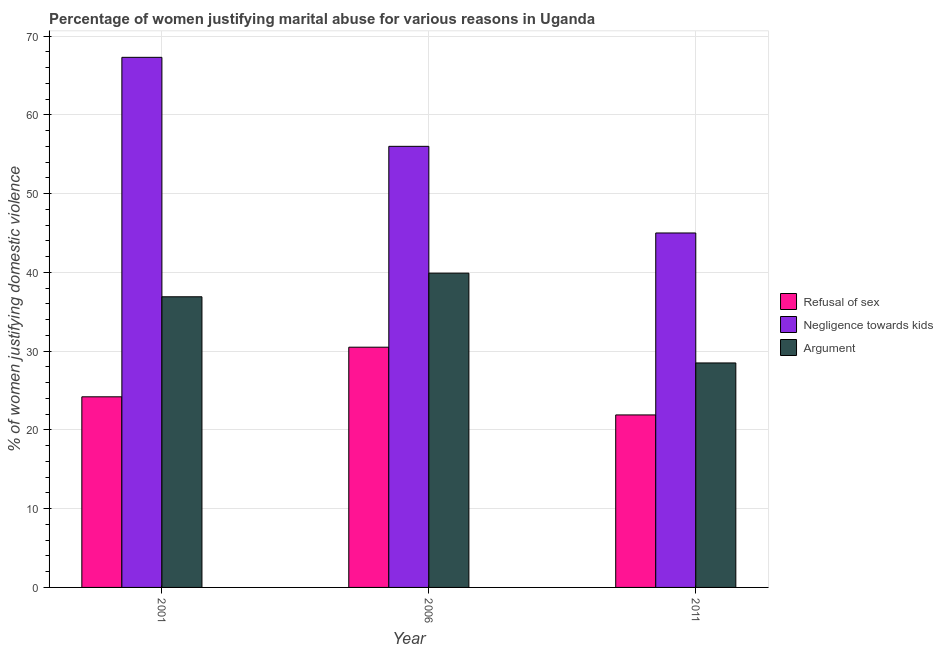How many different coloured bars are there?
Your answer should be very brief. 3. Are the number of bars per tick equal to the number of legend labels?
Ensure brevity in your answer.  Yes. How many bars are there on the 1st tick from the left?
Offer a terse response. 3. How many bars are there on the 2nd tick from the right?
Offer a very short reply. 3. In how many cases, is the number of bars for a given year not equal to the number of legend labels?
Provide a succinct answer. 0. What is the percentage of women justifying domestic violence due to refusal of sex in 2011?
Provide a succinct answer. 21.9. Across all years, what is the maximum percentage of women justifying domestic violence due to refusal of sex?
Make the answer very short. 30.5. In which year was the percentage of women justifying domestic violence due to arguments minimum?
Your answer should be very brief. 2011. What is the total percentage of women justifying domestic violence due to refusal of sex in the graph?
Offer a terse response. 76.6. What is the difference between the percentage of women justifying domestic violence due to refusal of sex in 2001 and that in 2006?
Ensure brevity in your answer.  -6.3. What is the difference between the percentage of women justifying domestic violence due to refusal of sex in 2006 and the percentage of women justifying domestic violence due to arguments in 2001?
Your answer should be very brief. 6.3. What is the average percentage of women justifying domestic violence due to negligence towards kids per year?
Give a very brief answer. 56.1. In how many years, is the percentage of women justifying domestic violence due to refusal of sex greater than 8 %?
Offer a very short reply. 3. What is the ratio of the percentage of women justifying domestic violence due to negligence towards kids in 2006 to that in 2011?
Give a very brief answer. 1.24. Is the difference between the percentage of women justifying domestic violence due to arguments in 2001 and 2006 greater than the difference between the percentage of women justifying domestic violence due to negligence towards kids in 2001 and 2006?
Give a very brief answer. No. What is the difference between the highest and the second highest percentage of women justifying domestic violence due to negligence towards kids?
Make the answer very short. 11.3. What is the difference between the highest and the lowest percentage of women justifying domestic violence due to negligence towards kids?
Your answer should be very brief. 22.3. Is the sum of the percentage of women justifying domestic violence due to refusal of sex in 2006 and 2011 greater than the maximum percentage of women justifying domestic violence due to arguments across all years?
Your response must be concise. Yes. What does the 1st bar from the left in 2011 represents?
Provide a succinct answer. Refusal of sex. What does the 1st bar from the right in 2011 represents?
Provide a succinct answer. Argument. Is it the case that in every year, the sum of the percentage of women justifying domestic violence due to refusal of sex and percentage of women justifying domestic violence due to negligence towards kids is greater than the percentage of women justifying domestic violence due to arguments?
Make the answer very short. Yes. Are all the bars in the graph horizontal?
Give a very brief answer. No. How many years are there in the graph?
Make the answer very short. 3. Are the values on the major ticks of Y-axis written in scientific E-notation?
Provide a short and direct response. No. Does the graph contain any zero values?
Your answer should be compact. No. Does the graph contain grids?
Give a very brief answer. Yes. Where does the legend appear in the graph?
Provide a succinct answer. Center right. How are the legend labels stacked?
Ensure brevity in your answer.  Vertical. What is the title of the graph?
Keep it short and to the point. Percentage of women justifying marital abuse for various reasons in Uganda. Does "Self-employed" appear as one of the legend labels in the graph?
Provide a succinct answer. No. What is the label or title of the Y-axis?
Make the answer very short. % of women justifying domestic violence. What is the % of women justifying domestic violence in Refusal of sex in 2001?
Ensure brevity in your answer.  24.2. What is the % of women justifying domestic violence of Negligence towards kids in 2001?
Your response must be concise. 67.3. What is the % of women justifying domestic violence of Argument in 2001?
Your response must be concise. 36.9. What is the % of women justifying domestic violence in Refusal of sex in 2006?
Your answer should be compact. 30.5. What is the % of women justifying domestic violence in Argument in 2006?
Make the answer very short. 39.9. What is the % of women justifying domestic violence of Refusal of sex in 2011?
Your answer should be very brief. 21.9. Across all years, what is the maximum % of women justifying domestic violence of Refusal of sex?
Ensure brevity in your answer.  30.5. Across all years, what is the maximum % of women justifying domestic violence in Negligence towards kids?
Keep it short and to the point. 67.3. Across all years, what is the maximum % of women justifying domestic violence in Argument?
Offer a terse response. 39.9. Across all years, what is the minimum % of women justifying domestic violence of Refusal of sex?
Your response must be concise. 21.9. Across all years, what is the minimum % of women justifying domestic violence of Argument?
Make the answer very short. 28.5. What is the total % of women justifying domestic violence in Refusal of sex in the graph?
Your response must be concise. 76.6. What is the total % of women justifying domestic violence in Negligence towards kids in the graph?
Keep it short and to the point. 168.3. What is the total % of women justifying domestic violence in Argument in the graph?
Keep it short and to the point. 105.3. What is the difference between the % of women justifying domestic violence of Argument in 2001 and that in 2006?
Your response must be concise. -3. What is the difference between the % of women justifying domestic violence in Negligence towards kids in 2001 and that in 2011?
Keep it short and to the point. 22.3. What is the difference between the % of women justifying domestic violence in Argument in 2001 and that in 2011?
Provide a succinct answer. 8.4. What is the difference between the % of women justifying domestic violence in Refusal of sex in 2001 and the % of women justifying domestic violence in Negligence towards kids in 2006?
Ensure brevity in your answer.  -31.8. What is the difference between the % of women justifying domestic violence in Refusal of sex in 2001 and the % of women justifying domestic violence in Argument in 2006?
Offer a terse response. -15.7. What is the difference between the % of women justifying domestic violence of Negligence towards kids in 2001 and the % of women justifying domestic violence of Argument in 2006?
Offer a very short reply. 27.4. What is the difference between the % of women justifying domestic violence in Refusal of sex in 2001 and the % of women justifying domestic violence in Negligence towards kids in 2011?
Offer a terse response. -20.8. What is the difference between the % of women justifying domestic violence in Negligence towards kids in 2001 and the % of women justifying domestic violence in Argument in 2011?
Offer a very short reply. 38.8. What is the difference between the % of women justifying domestic violence in Refusal of sex in 2006 and the % of women justifying domestic violence in Negligence towards kids in 2011?
Give a very brief answer. -14.5. What is the difference between the % of women justifying domestic violence of Negligence towards kids in 2006 and the % of women justifying domestic violence of Argument in 2011?
Give a very brief answer. 27.5. What is the average % of women justifying domestic violence in Refusal of sex per year?
Give a very brief answer. 25.53. What is the average % of women justifying domestic violence of Negligence towards kids per year?
Provide a succinct answer. 56.1. What is the average % of women justifying domestic violence in Argument per year?
Your answer should be very brief. 35.1. In the year 2001, what is the difference between the % of women justifying domestic violence of Refusal of sex and % of women justifying domestic violence of Negligence towards kids?
Your answer should be compact. -43.1. In the year 2001, what is the difference between the % of women justifying domestic violence in Refusal of sex and % of women justifying domestic violence in Argument?
Your response must be concise. -12.7. In the year 2001, what is the difference between the % of women justifying domestic violence of Negligence towards kids and % of women justifying domestic violence of Argument?
Keep it short and to the point. 30.4. In the year 2006, what is the difference between the % of women justifying domestic violence in Refusal of sex and % of women justifying domestic violence in Negligence towards kids?
Make the answer very short. -25.5. In the year 2006, what is the difference between the % of women justifying domestic violence of Negligence towards kids and % of women justifying domestic violence of Argument?
Your response must be concise. 16.1. In the year 2011, what is the difference between the % of women justifying domestic violence of Refusal of sex and % of women justifying domestic violence of Negligence towards kids?
Give a very brief answer. -23.1. In the year 2011, what is the difference between the % of women justifying domestic violence in Negligence towards kids and % of women justifying domestic violence in Argument?
Your response must be concise. 16.5. What is the ratio of the % of women justifying domestic violence of Refusal of sex in 2001 to that in 2006?
Provide a short and direct response. 0.79. What is the ratio of the % of women justifying domestic violence in Negligence towards kids in 2001 to that in 2006?
Keep it short and to the point. 1.2. What is the ratio of the % of women justifying domestic violence in Argument in 2001 to that in 2006?
Your answer should be very brief. 0.92. What is the ratio of the % of women justifying domestic violence in Refusal of sex in 2001 to that in 2011?
Provide a succinct answer. 1.1. What is the ratio of the % of women justifying domestic violence in Negligence towards kids in 2001 to that in 2011?
Keep it short and to the point. 1.5. What is the ratio of the % of women justifying domestic violence of Argument in 2001 to that in 2011?
Provide a short and direct response. 1.29. What is the ratio of the % of women justifying domestic violence of Refusal of sex in 2006 to that in 2011?
Offer a very short reply. 1.39. What is the ratio of the % of women justifying domestic violence of Negligence towards kids in 2006 to that in 2011?
Keep it short and to the point. 1.24. What is the ratio of the % of women justifying domestic violence of Argument in 2006 to that in 2011?
Ensure brevity in your answer.  1.4. What is the difference between the highest and the second highest % of women justifying domestic violence in Negligence towards kids?
Offer a very short reply. 11.3. What is the difference between the highest and the lowest % of women justifying domestic violence of Refusal of sex?
Keep it short and to the point. 8.6. What is the difference between the highest and the lowest % of women justifying domestic violence of Negligence towards kids?
Provide a succinct answer. 22.3. 